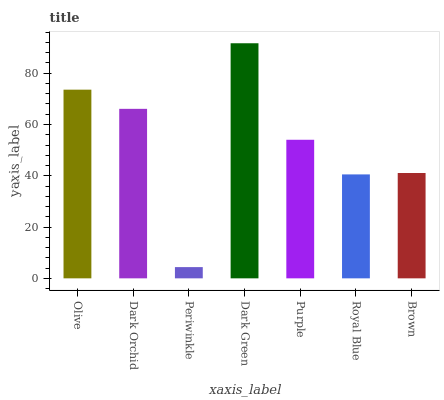Is Periwinkle the minimum?
Answer yes or no. Yes. Is Dark Green the maximum?
Answer yes or no. Yes. Is Dark Orchid the minimum?
Answer yes or no. No. Is Dark Orchid the maximum?
Answer yes or no. No. Is Olive greater than Dark Orchid?
Answer yes or no. Yes. Is Dark Orchid less than Olive?
Answer yes or no. Yes. Is Dark Orchid greater than Olive?
Answer yes or no. No. Is Olive less than Dark Orchid?
Answer yes or no. No. Is Purple the high median?
Answer yes or no. Yes. Is Purple the low median?
Answer yes or no. Yes. Is Royal Blue the high median?
Answer yes or no. No. Is Brown the low median?
Answer yes or no. No. 